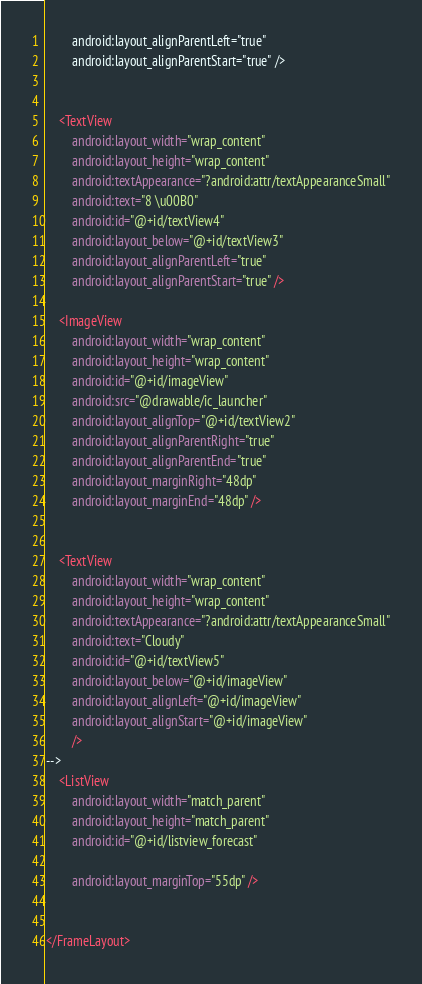Convert code to text. <code><loc_0><loc_0><loc_500><loc_500><_XML_>        android:layout_alignParentLeft="true"
        android:layout_alignParentStart="true" />


    <TextView
        android:layout_width="wrap_content"
        android:layout_height="wrap_content"
        android:textAppearance="?android:attr/textAppearanceSmall"
        android:text="8 \u00B0"
        android:id="@+id/textView4"
        android:layout_below="@+id/textView3"
        android:layout_alignParentLeft="true"
        android:layout_alignParentStart="true" />

    <ImageView
        android:layout_width="wrap_content"
        android:layout_height="wrap_content"
        android:id="@+id/imageView"
        android:src="@drawable/ic_launcher"
        android:layout_alignTop="@+id/textView2"
        android:layout_alignParentRight="true"
        android:layout_alignParentEnd="true"
        android:layout_marginRight="48dp"
        android:layout_marginEnd="48dp" />


    <TextView
        android:layout_width="wrap_content"
        android:layout_height="wrap_content"
        android:textAppearance="?android:attr/textAppearanceSmall"
        android:text="Cloudy"
        android:id="@+id/textView5"
        android:layout_below="@+id/imageView"
        android:layout_alignLeft="@+id/imageView"
        android:layout_alignStart="@+id/imageView"
        />
-->
    <ListView
        android:layout_width="match_parent"
        android:layout_height="match_parent"
        android:id="@+id/listview_forecast"

        android:layout_marginTop="55dp" />


</FrameLayout>
</code> 